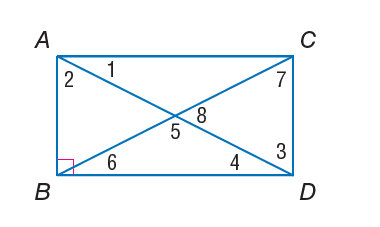Answer the mathemtical geometry problem and directly provide the correct option letter.
Question: Quadrilateral A B C D is a rectangle. m \angle 2 = 40. Find m \angle 7.
Choices: A: 40 B: 45 C: 50 D: 90 A 